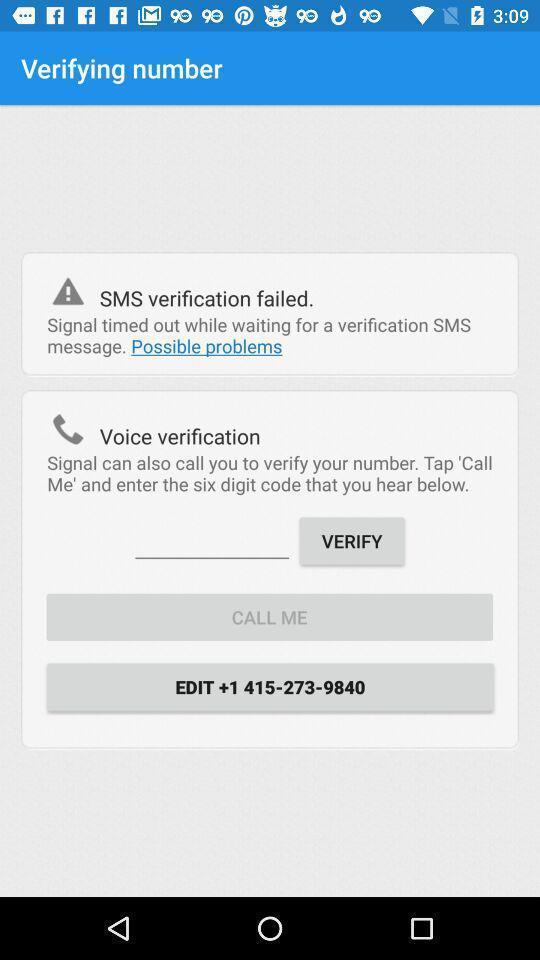Give me a narrative description of this picture. Page for verifying number. 